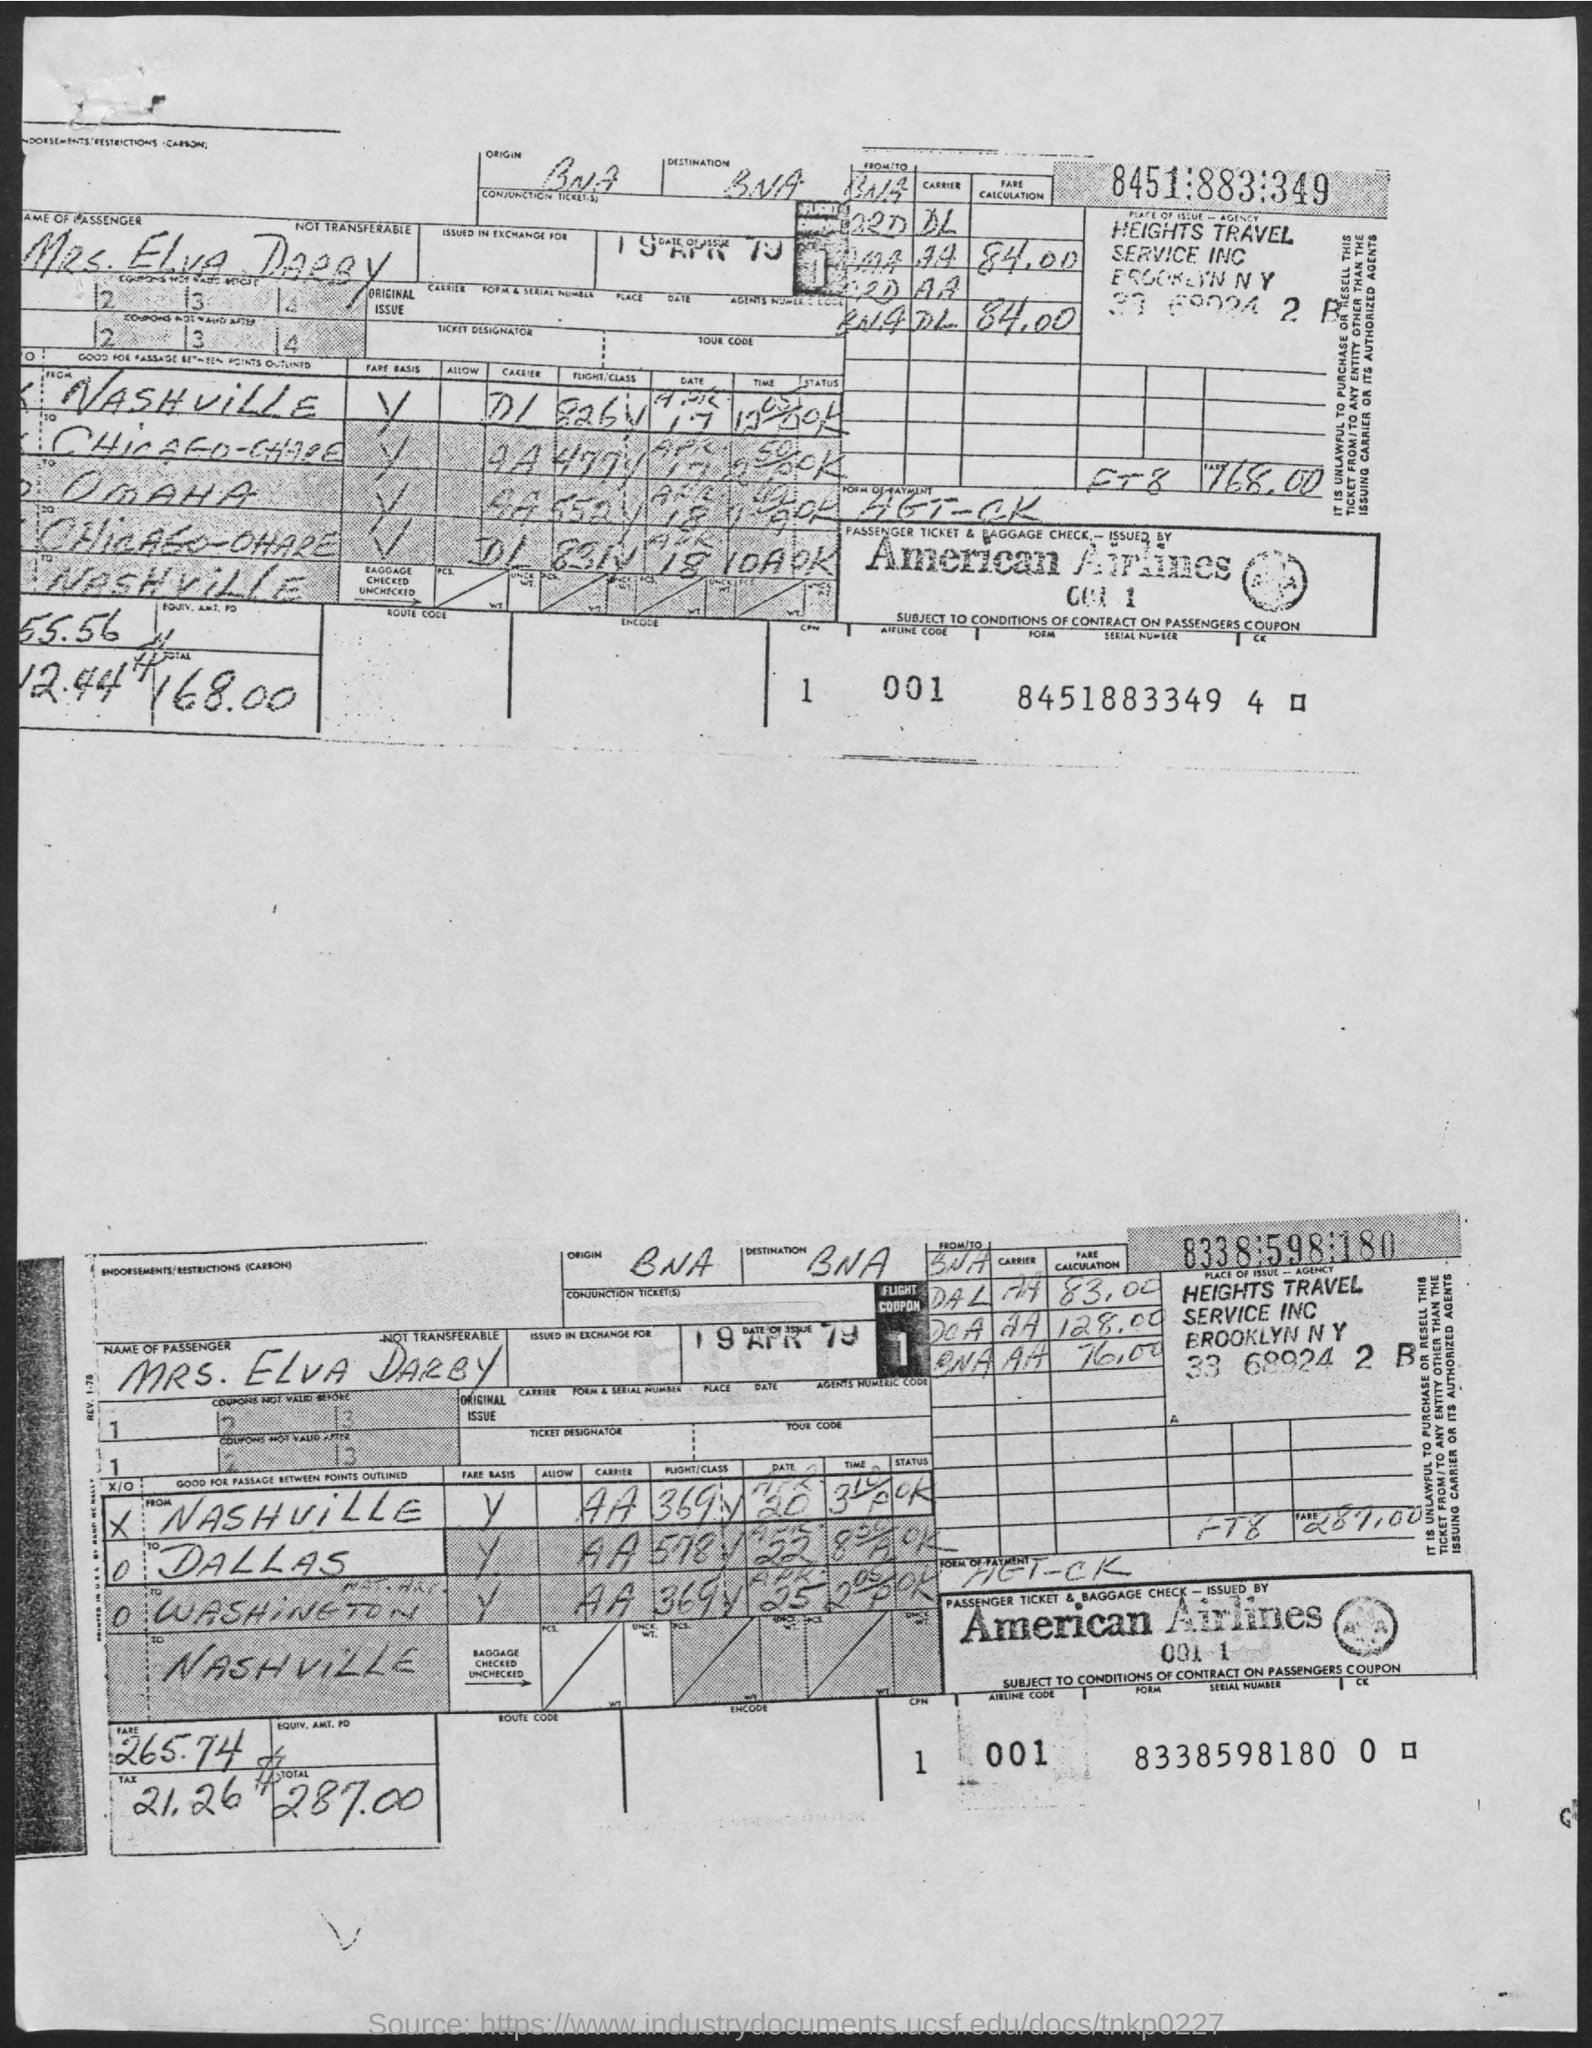Point out several critical features in this image. On April 19th, 1979, the date of issue was. 